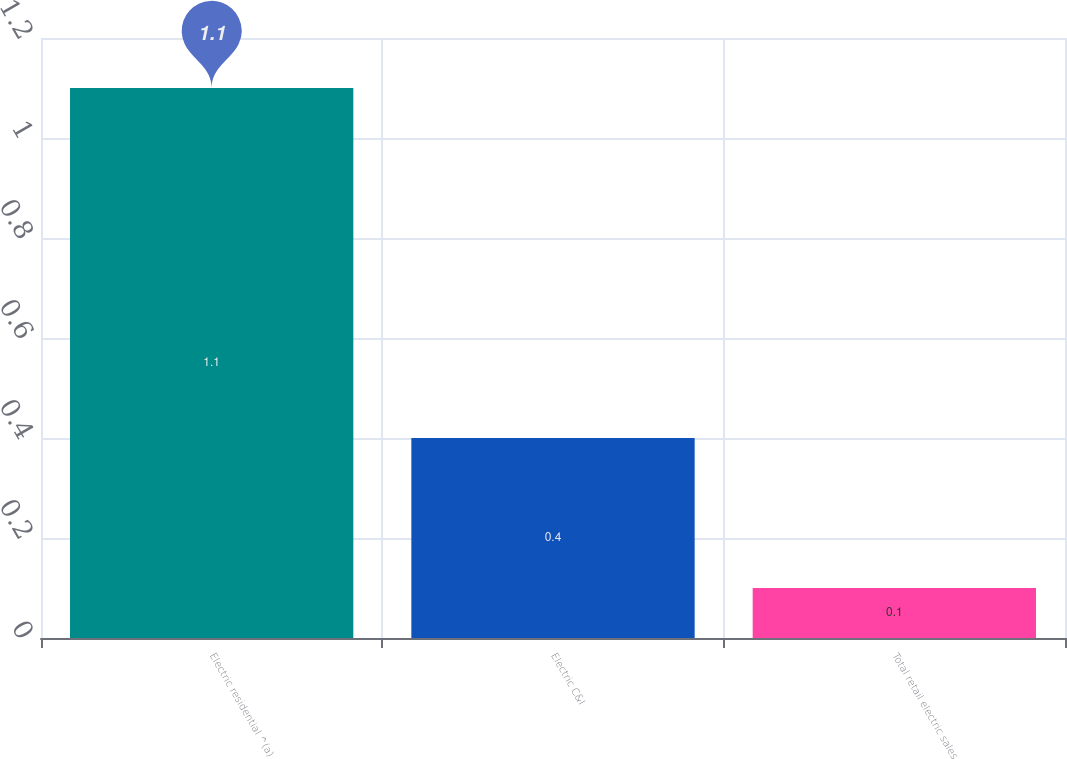Convert chart to OTSL. <chart><loc_0><loc_0><loc_500><loc_500><bar_chart><fcel>Electric residential ^(a)<fcel>Electric C&I<fcel>Total retail electric sales<nl><fcel>1.1<fcel>0.4<fcel>0.1<nl></chart> 